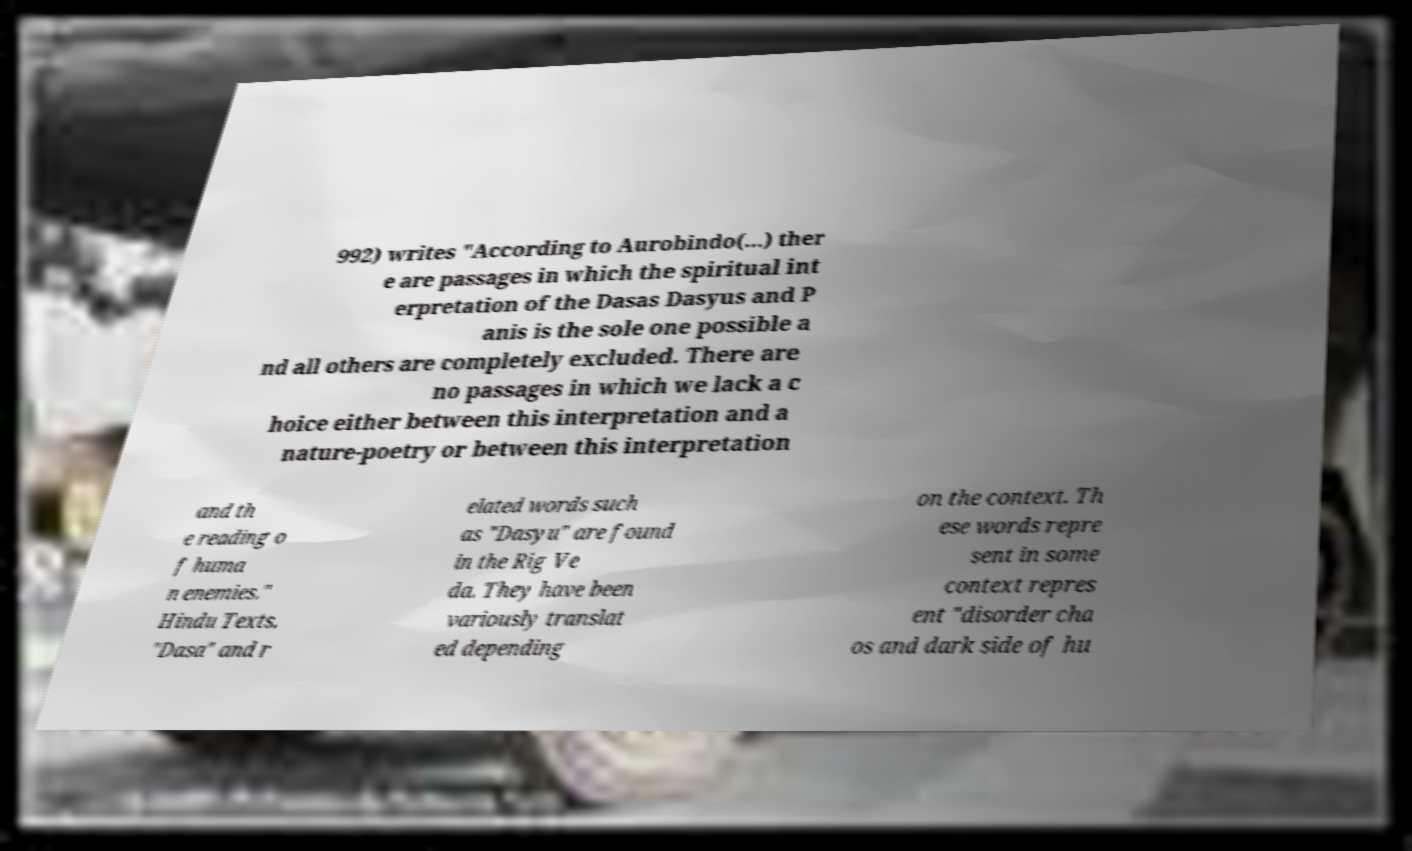Please identify and transcribe the text found in this image. 992) writes "According to Aurobindo(...) ther e are passages in which the spiritual int erpretation of the Dasas Dasyus and P anis is the sole one possible a nd all others are completely excluded. There are no passages in which we lack a c hoice either between this interpretation and a nature-poetry or between this interpretation and th e reading o f huma n enemies." Hindu Texts. "Dasa" and r elated words such as "Dasyu" are found in the Rig Ve da. They have been variously translat ed depending on the context. Th ese words repre sent in some context repres ent "disorder cha os and dark side of hu 